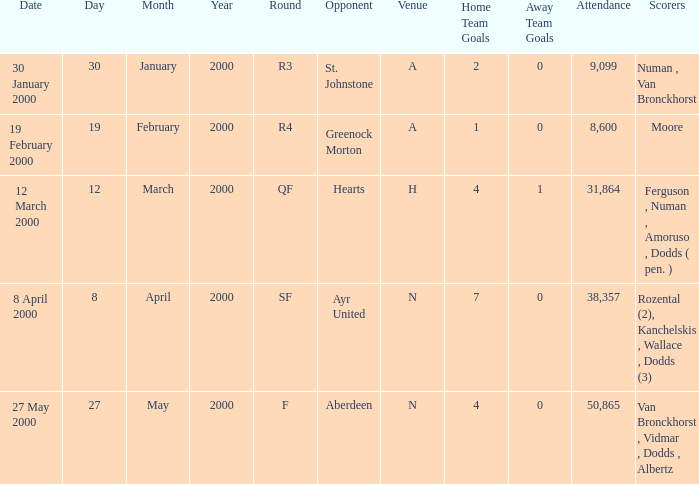What place was on 27 may 2000? N. 